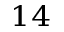Convert formula to latex. <formula><loc_0><loc_0><loc_500><loc_500>^ { 1 4 }</formula> 